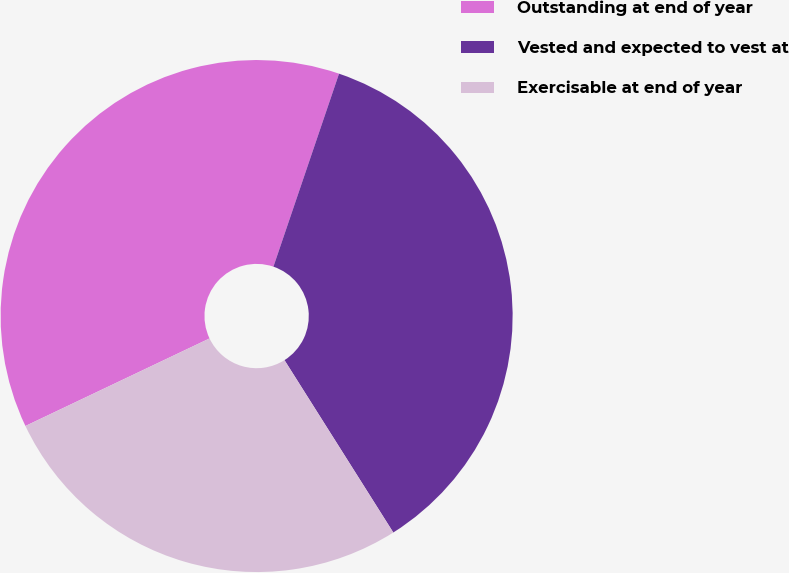Convert chart to OTSL. <chart><loc_0><loc_0><loc_500><loc_500><pie_chart><fcel>Outstanding at end of year<fcel>Vested and expected to vest at<fcel>Exercisable at end of year<nl><fcel>37.28%<fcel>35.82%<fcel>26.9%<nl></chart> 